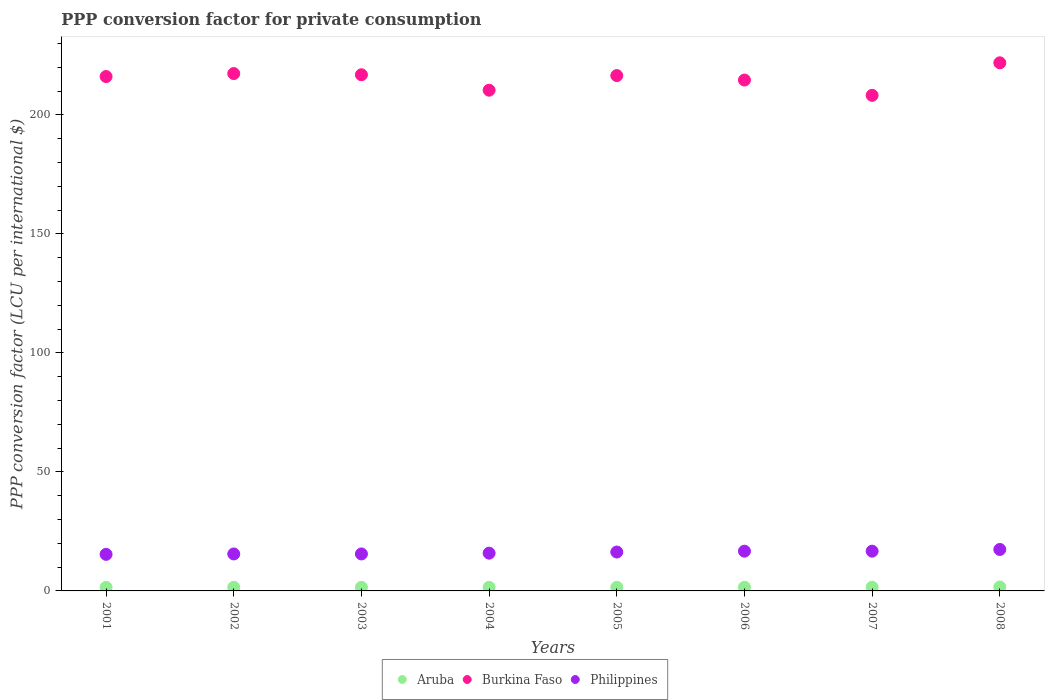Is the number of dotlines equal to the number of legend labels?
Provide a succinct answer. Yes. What is the PPP conversion factor for private consumption in Philippines in 2003?
Keep it short and to the point. 15.54. Across all years, what is the maximum PPP conversion factor for private consumption in Burkina Faso?
Your response must be concise. 221.91. Across all years, what is the minimum PPP conversion factor for private consumption in Philippines?
Provide a short and direct response. 15.36. In which year was the PPP conversion factor for private consumption in Burkina Faso maximum?
Make the answer very short. 2008. In which year was the PPP conversion factor for private consumption in Burkina Faso minimum?
Offer a terse response. 2007. What is the total PPP conversion factor for private consumption in Philippines in the graph?
Provide a short and direct response. 129.47. What is the difference between the PPP conversion factor for private consumption in Burkina Faso in 2003 and that in 2005?
Make the answer very short. 0.35. What is the difference between the PPP conversion factor for private consumption in Aruba in 2001 and the PPP conversion factor for private consumption in Burkina Faso in 2008?
Keep it short and to the point. -220.42. What is the average PPP conversion factor for private consumption in Philippines per year?
Your response must be concise. 16.18. In the year 2006, what is the difference between the PPP conversion factor for private consumption in Burkina Faso and PPP conversion factor for private consumption in Aruba?
Your answer should be compact. 213.12. In how many years, is the PPP conversion factor for private consumption in Aruba greater than 140 LCU?
Offer a very short reply. 0. What is the ratio of the PPP conversion factor for private consumption in Burkina Faso in 2006 to that in 2008?
Keep it short and to the point. 0.97. Is the PPP conversion factor for private consumption in Burkina Faso in 2003 less than that in 2006?
Provide a short and direct response. No. What is the difference between the highest and the second highest PPP conversion factor for private consumption in Aruba?
Offer a very short reply. 0.08. What is the difference between the highest and the lowest PPP conversion factor for private consumption in Philippines?
Keep it short and to the point. 2.06. In how many years, is the PPP conversion factor for private consumption in Aruba greater than the average PPP conversion factor for private consumption in Aruba taken over all years?
Your answer should be very brief. 2. Is the sum of the PPP conversion factor for private consumption in Aruba in 2003 and 2004 greater than the maximum PPP conversion factor for private consumption in Philippines across all years?
Offer a terse response. No. Is it the case that in every year, the sum of the PPP conversion factor for private consumption in Aruba and PPP conversion factor for private consumption in Burkina Faso  is greater than the PPP conversion factor for private consumption in Philippines?
Your response must be concise. Yes. Is the PPP conversion factor for private consumption in Aruba strictly greater than the PPP conversion factor for private consumption in Burkina Faso over the years?
Your answer should be compact. No. How many dotlines are there?
Ensure brevity in your answer.  3. How many years are there in the graph?
Provide a succinct answer. 8. Does the graph contain any zero values?
Offer a very short reply. No. Does the graph contain grids?
Provide a succinct answer. No. What is the title of the graph?
Make the answer very short. PPP conversion factor for private consumption. What is the label or title of the Y-axis?
Your answer should be compact. PPP conversion factor (LCU per international $). What is the PPP conversion factor (LCU per international $) of Aruba in 2001?
Your answer should be very brief. 1.49. What is the PPP conversion factor (LCU per international $) in Burkina Faso in 2001?
Provide a succinct answer. 216.13. What is the PPP conversion factor (LCU per international $) in Philippines in 2001?
Give a very brief answer. 15.36. What is the PPP conversion factor (LCU per international $) in Aruba in 2002?
Your response must be concise. 1.52. What is the PPP conversion factor (LCU per international $) of Burkina Faso in 2002?
Your response must be concise. 217.39. What is the PPP conversion factor (LCU per international $) in Philippines in 2002?
Offer a very short reply. 15.53. What is the PPP conversion factor (LCU per international $) of Aruba in 2003?
Provide a short and direct response. 1.54. What is the PPP conversion factor (LCU per international $) in Burkina Faso in 2003?
Your response must be concise. 216.89. What is the PPP conversion factor (LCU per international $) in Philippines in 2003?
Your answer should be compact. 15.54. What is the PPP conversion factor (LCU per international $) in Aruba in 2004?
Your answer should be compact. 1.53. What is the PPP conversion factor (LCU per international $) in Burkina Faso in 2004?
Keep it short and to the point. 210.39. What is the PPP conversion factor (LCU per international $) of Philippines in 2004?
Provide a succinct answer. 15.86. What is the PPP conversion factor (LCU per international $) of Aruba in 2005?
Your answer should be very brief. 1.53. What is the PPP conversion factor (LCU per international $) in Burkina Faso in 2005?
Ensure brevity in your answer.  216.54. What is the PPP conversion factor (LCU per international $) of Philippines in 2005?
Keep it short and to the point. 16.34. What is the PPP conversion factor (LCU per international $) of Aruba in 2006?
Ensure brevity in your answer.  1.54. What is the PPP conversion factor (LCU per international $) of Burkina Faso in 2006?
Provide a succinct answer. 214.66. What is the PPP conversion factor (LCU per international $) in Philippines in 2006?
Ensure brevity in your answer.  16.7. What is the PPP conversion factor (LCU per international $) of Aruba in 2007?
Your answer should be compact. 1.58. What is the PPP conversion factor (LCU per international $) of Burkina Faso in 2007?
Your answer should be very brief. 208.23. What is the PPP conversion factor (LCU per international $) in Philippines in 2007?
Your response must be concise. 16.71. What is the PPP conversion factor (LCU per international $) in Aruba in 2008?
Keep it short and to the point. 1.66. What is the PPP conversion factor (LCU per international $) in Burkina Faso in 2008?
Ensure brevity in your answer.  221.91. What is the PPP conversion factor (LCU per international $) in Philippines in 2008?
Provide a short and direct response. 17.42. Across all years, what is the maximum PPP conversion factor (LCU per international $) of Aruba?
Keep it short and to the point. 1.66. Across all years, what is the maximum PPP conversion factor (LCU per international $) of Burkina Faso?
Provide a short and direct response. 221.91. Across all years, what is the maximum PPP conversion factor (LCU per international $) of Philippines?
Your answer should be compact. 17.42. Across all years, what is the minimum PPP conversion factor (LCU per international $) of Aruba?
Ensure brevity in your answer.  1.49. Across all years, what is the minimum PPP conversion factor (LCU per international $) of Burkina Faso?
Provide a short and direct response. 208.23. Across all years, what is the minimum PPP conversion factor (LCU per international $) in Philippines?
Offer a terse response. 15.36. What is the total PPP conversion factor (LCU per international $) in Aruba in the graph?
Offer a very short reply. 12.39. What is the total PPP conversion factor (LCU per international $) of Burkina Faso in the graph?
Your answer should be very brief. 1722.13. What is the total PPP conversion factor (LCU per international $) in Philippines in the graph?
Keep it short and to the point. 129.47. What is the difference between the PPP conversion factor (LCU per international $) of Aruba in 2001 and that in 2002?
Provide a succinct answer. -0.03. What is the difference between the PPP conversion factor (LCU per international $) in Burkina Faso in 2001 and that in 2002?
Your answer should be very brief. -1.25. What is the difference between the PPP conversion factor (LCU per international $) of Philippines in 2001 and that in 2002?
Your response must be concise. -0.17. What is the difference between the PPP conversion factor (LCU per international $) of Aruba in 2001 and that in 2003?
Provide a short and direct response. -0.05. What is the difference between the PPP conversion factor (LCU per international $) of Burkina Faso in 2001 and that in 2003?
Your answer should be compact. -0.75. What is the difference between the PPP conversion factor (LCU per international $) in Philippines in 2001 and that in 2003?
Offer a terse response. -0.17. What is the difference between the PPP conversion factor (LCU per international $) of Aruba in 2001 and that in 2004?
Ensure brevity in your answer.  -0.04. What is the difference between the PPP conversion factor (LCU per international $) in Burkina Faso in 2001 and that in 2004?
Your response must be concise. 5.75. What is the difference between the PPP conversion factor (LCU per international $) in Philippines in 2001 and that in 2004?
Make the answer very short. -0.5. What is the difference between the PPP conversion factor (LCU per international $) in Aruba in 2001 and that in 2005?
Keep it short and to the point. -0.04. What is the difference between the PPP conversion factor (LCU per international $) in Burkina Faso in 2001 and that in 2005?
Give a very brief answer. -0.4. What is the difference between the PPP conversion factor (LCU per international $) of Philippines in 2001 and that in 2005?
Offer a very short reply. -0.98. What is the difference between the PPP conversion factor (LCU per international $) of Aruba in 2001 and that in 2006?
Ensure brevity in your answer.  -0.05. What is the difference between the PPP conversion factor (LCU per international $) in Burkina Faso in 2001 and that in 2006?
Provide a succinct answer. 1.47. What is the difference between the PPP conversion factor (LCU per international $) of Philippines in 2001 and that in 2006?
Your answer should be very brief. -1.34. What is the difference between the PPP conversion factor (LCU per international $) of Aruba in 2001 and that in 2007?
Offer a terse response. -0.09. What is the difference between the PPP conversion factor (LCU per international $) of Burkina Faso in 2001 and that in 2007?
Your answer should be compact. 7.9. What is the difference between the PPP conversion factor (LCU per international $) of Philippines in 2001 and that in 2007?
Provide a short and direct response. -1.35. What is the difference between the PPP conversion factor (LCU per international $) of Aruba in 2001 and that in 2008?
Your answer should be compact. -0.17. What is the difference between the PPP conversion factor (LCU per international $) in Burkina Faso in 2001 and that in 2008?
Your response must be concise. -5.77. What is the difference between the PPP conversion factor (LCU per international $) of Philippines in 2001 and that in 2008?
Give a very brief answer. -2.06. What is the difference between the PPP conversion factor (LCU per international $) in Aruba in 2002 and that in 2003?
Keep it short and to the point. -0.02. What is the difference between the PPP conversion factor (LCU per international $) in Burkina Faso in 2002 and that in 2003?
Give a very brief answer. 0.5. What is the difference between the PPP conversion factor (LCU per international $) of Philippines in 2002 and that in 2003?
Make the answer very short. -0. What is the difference between the PPP conversion factor (LCU per international $) of Aruba in 2002 and that in 2004?
Keep it short and to the point. -0.02. What is the difference between the PPP conversion factor (LCU per international $) of Burkina Faso in 2002 and that in 2004?
Ensure brevity in your answer.  7. What is the difference between the PPP conversion factor (LCU per international $) in Philippines in 2002 and that in 2004?
Your response must be concise. -0.33. What is the difference between the PPP conversion factor (LCU per international $) in Aruba in 2002 and that in 2005?
Keep it short and to the point. -0.02. What is the difference between the PPP conversion factor (LCU per international $) of Burkina Faso in 2002 and that in 2005?
Your response must be concise. 0.85. What is the difference between the PPP conversion factor (LCU per international $) in Philippines in 2002 and that in 2005?
Your response must be concise. -0.81. What is the difference between the PPP conversion factor (LCU per international $) in Aruba in 2002 and that in 2006?
Offer a very short reply. -0.02. What is the difference between the PPP conversion factor (LCU per international $) of Burkina Faso in 2002 and that in 2006?
Keep it short and to the point. 2.72. What is the difference between the PPP conversion factor (LCU per international $) of Philippines in 2002 and that in 2006?
Your response must be concise. -1.17. What is the difference between the PPP conversion factor (LCU per international $) of Aruba in 2002 and that in 2007?
Your answer should be very brief. -0.06. What is the difference between the PPP conversion factor (LCU per international $) of Burkina Faso in 2002 and that in 2007?
Your answer should be very brief. 9.16. What is the difference between the PPP conversion factor (LCU per international $) in Philippines in 2002 and that in 2007?
Your response must be concise. -1.17. What is the difference between the PPP conversion factor (LCU per international $) of Aruba in 2002 and that in 2008?
Make the answer very short. -0.14. What is the difference between the PPP conversion factor (LCU per international $) in Burkina Faso in 2002 and that in 2008?
Provide a short and direct response. -4.52. What is the difference between the PPP conversion factor (LCU per international $) in Philippines in 2002 and that in 2008?
Your answer should be very brief. -1.88. What is the difference between the PPP conversion factor (LCU per international $) in Aruba in 2003 and that in 2004?
Your answer should be compact. 0. What is the difference between the PPP conversion factor (LCU per international $) of Burkina Faso in 2003 and that in 2004?
Ensure brevity in your answer.  6.5. What is the difference between the PPP conversion factor (LCU per international $) of Philippines in 2003 and that in 2004?
Your answer should be compact. -0.33. What is the difference between the PPP conversion factor (LCU per international $) in Aruba in 2003 and that in 2005?
Keep it short and to the point. 0. What is the difference between the PPP conversion factor (LCU per international $) of Burkina Faso in 2003 and that in 2005?
Provide a short and direct response. 0.35. What is the difference between the PPP conversion factor (LCU per international $) in Philippines in 2003 and that in 2005?
Provide a short and direct response. -0.81. What is the difference between the PPP conversion factor (LCU per international $) of Aruba in 2003 and that in 2006?
Offer a terse response. -0. What is the difference between the PPP conversion factor (LCU per international $) in Burkina Faso in 2003 and that in 2006?
Keep it short and to the point. 2.22. What is the difference between the PPP conversion factor (LCU per international $) in Philippines in 2003 and that in 2006?
Your answer should be compact. -1.16. What is the difference between the PPP conversion factor (LCU per international $) of Aruba in 2003 and that in 2007?
Your response must be concise. -0.04. What is the difference between the PPP conversion factor (LCU per international $) of Burkina Faso in 2003 and that in 2007?
Offer a terse response. 8.66. What is the difference between the PPP conversion factor (LCU per international $) of Philippines in 2003 and that in 2007?
Give a very brief answer. -1.17. What is the difference between the PPP conversion factor (LCU per international $) in Aruba in 2003 and that in 2008?
Make the answer very short. -0.12. What is the difference between the PPP conversion factor (LCU per international $) in Burkina Faso in 2003 and that in 2008?
Offer a terse response. -5.02. What is the difference between the PPP conversion factor (LCU per international $) in Philippines in 2003 and that in 2008?
Offer a very short reply. -1.88. What is the difference between the PPP conversion factor (LCU per international $) in Aruba in 2004 and that in 2005?
Your response must be concise. -0. What is the difference between the PPP conversion factor (LCU per international $) of Burkina Faso in 2004 and that in 2005?
Provide a succinct answer. -6.15. What is the difference between the PPP conversion factor (LCU per international $) in Philippines in 2004 and that in 2005?
Offer a terse response. -0.48. What is the difference between the PPP conversion factor (LCU per international $) in Aruba in 2004 and that in 2006?
Your answer should be compact. -0.01. What is the difference between the PPP conversion factor (LCU per international $) in Burkina Faso in 2004 and that in 2006?
Provide a short and direct response. -4.28. What is the difference between the PPP conversion factor (LCU per international $) in Philippines in 2004 and that in 2006?
Provide a short and direct response. -0.84. What is the difference between the PPP conversion factor (LCU per international $) of Aruba in 2004 and that in 2007?
Keep it short and to the point. -0.04. What is the difference between the PPP conversion factor (LCU per international $) of Burkina Faso in 2004 and that in 2007?
Make the answer very short. 2.16. What is the difference between the PPP conversion factor (LCU per international $) of Philippines in 2004 and that in 2007?
Your response must be concise. -0.84. What is the difference between the PPP conversion factor (LCU per international $) in Aruba in 2004 and that in 2008?
Your response must be concise. -0.12. What is the difference between the PPP conversion factor (LCU per international $) in Burkina Faso in 2004 and that in 2008?
Your answer should be compact. -11.52. What is the difference between the PPP conversion factor (LCU per international $) of Philippines in 2004 and that in 2008?
Provide a short and direct response. -1.56. What is the difference between the PPP conversion factor (LCU per international $) of Aruba in 2005 and that in 2006?
Your response must be concise. -0.01. What is the difference between the PPP conversion factor (LCU per international $) of Burkina Faso in 2005 and that in 2006?
Your response must be concise. 1.87. What is the difference between the PPP conversion factor (LCU per international $) in Philippines in 2005 and that in 2006?
Your answer should be compact. -0.36. What is the difference between the PPP conversion factor (LCU per international $) in Aruba in 2005 and that in 2007?
Ensure brevity in your answer.  -0.04. What is the difference between the PPP conversion factor (LCU per international $) in Burkina Faso in 2005 and that in 2007?
Your response must be concise. 8.31. What is the difference between the PPP conversion factor (LCU per international $) of Philippines in 2005 and that in 2007?
Make the answer very short. -0.37. What is the difference between the PPP conversion factor (LCU per international $) of Aruba in 2005 and that in 2008?
Ensure brevity in your answer.  -0.12. What is the difference between the PPP conversion factor (LCU per international $) in Burkina Faso in 2005 and that in 2008?
Keep it short and to the point. -5.37. What is the difference between the PPP conversion factor (LCU per international $) of Philippines in 2005 and that in 2008?
Your answer should be compact. -1.08. What is the difference between the PPP conversion factor (LCU per international $) in Aruba in 2006 and that in 2007?
Your answer should be compact. -0.04. What is the difference between the PPP conversion factor (LCU per international $) of Burkina Faso in 2006 and that in 2007?
Provide a short and direct response. 6.44. What is the difference between the PPP conversion factor (LCU per international $) of Philippines in 2006 and that in 2007?
Offer a terse response. -0.01. What is the difference between the PPP conversion factor (LCU per international $) in Aruba in 2006 and that in 2008?
Your response must be concise. -0.12. What is the difference between the PPP conversion factor (LCU per international $) in Burkina Faso in 2006 and that in 2008?
Provide a succinct answer. -7.24. What is the difference between the PPP conversion factor (LCU per international $) of Philippines in 2006 and that in 2008?
Provide a succinct answer. -0.72. What is the difference between the PPP conversion factor (LCU per international $) in Aruba in 2007 and that in 2008?
Make the answer very short. -0.08. What is the difference between the PPP conversion factor (LCU per international $) in Burkina Faso in 2007 and that in 2008?
Ensure brevity in your answer.  -13.68. What is the difference between the PPP conversion factor (LCU per international $) in Philippines in 2007 and that in 2008?
Give a very brief answer. -0.71. What is the difference between the PPP conversion factor (LCU per international $) of Aruba in 2001 and the PPP conversion factor (LCU per international $) of Burkina Faso in 2002?
Your answer should be very brief. -215.9. What is the difference between the PPP conversion factor (LCU per international $) in Aruba in 2001 and the PPP conversion factor (LCU per international $) in Philippines in 2002?
Ensure brevity in your answer.  -14.04. What is the difference between the PPP conversion factor (LCU per international $) in Burkina Faso in 2001 and the PPP conversion factor (LCU per international $) in Philippines in 2002?
Provide a succinct answer. 200.6. What is the difference between the PPP conversion factor (LCU per international $) of Aruba in 2001 and the PPP conversion factor (LCU per international $) of Burkina Faso in 2003?
Ensure brevity in your answer.  -215.4. What is the difference between the PPP conversion factor (LCU per international $) in Aruba in 2001 and the PPP conversion factor (LCU per international $) in Philippines in 2003?
Ensure brevity in your answer.  -14.05. What is the difference between the PPP conversion factor (LCU per international $) in Burkina Faso in 2001 and the PPP conversion factor (LCU per international $) in Philippines in 2003?
Ensure brevity in your answer.  200.6. What is the difference between the PPP conversion factor (LCU per international $) of Aruba in 2001 and the PPP conversion factor (LCU per international $) of Burkina Faso in 2004?
Keep it short and to the point. -208.9. What is the difference between the PPP conversion factor (LCU per international $) of Aruba in 2001 and the PPP conversion factor (LCU per international $) of Philippines in 2004?
Your answer should be compact. -14.37. What is the difference between the PPP conversion factor (LCU per international $) of Burkina Faso in 2001 and the PPP conversion factor (LCU per international $) of Philippines in 2004?
Your answer should be very brief. 200.27. What is the difference between the PPP conversion factor (LCU per international $) in Aruba in 2001 and the PPP conversion factor (LCU per international $) in Burkina Faso in 2005?
Your response must be concise. -215.05. What is the difference between the PPP conversion factor (LCU per international $) in Aruba in 2001 and the PPP conversion factor (LCU per international $) in Philippines in 2005?
Make the answer very short. -14.85. What is the difference between the PPP conversion factor (LCU per international $) in Burkina Faso in 2001 and the PPP conversion factor (LCU per international $) in Philippines in 2005?
Make the answer very short. 199.79. What is the difference between the PPP conversion factor (LCU per international $) of Aruba in 2001 and the PPP conversion factor (LCU per international $) of Burkina Faso in 2006?
Ensure brevity in your answer.  -213.17. What is the difference between the PPP conversion factor (LCU per international $) in Aruba in 2001 and the PPP conversion factor (LCU per international $) in Philippines in 2006?
Keep it short and to the point. -15.21. What is the difference between the PPP conversion factor (LCU per international $) in Burkina Faso in 2001 and the PPP conversion factor (LCU per international $) in Philippines in 2006?
Ensure brevity in your answer.  199.43. What is the difference between the PPP conversion factor (LCU per international $) in Aruba in 2001 and the PPP conversion factor (LCU per international $) in Burkina Faso in 2007?
Your answer should be very brief. -206.74. What is the difference between the PPP conversion factor (LCU per international $) of Aruba in 2001 and the PPP conversion factor (LCU per international $) of Philippines in 2007?
Keep it short and to the point. -15.22. What is the difference between the PPP conversion factor (LCU per international $) of Burkina Faso in 2001 and the PPP conversion factor (LCU per international $) of Philippines in 2007?
Provide a succinct answer. 199.43. What is the difference between the PPP conversion factor (LCU per international $) in Aruba in 2001 and the PPP conversion factor (LCU per international $) in Burkina Faso in 2008?
Your answer should be compact. -220.42. What is the difference between the PPP conversion factor (LCU per international $) of Aruba in 2001 and the PPP conversion factor (LCU per international $) of Philippines in 2008?
Make the answer very short. -15.93. What is the difference between the PPP conversion factor (LCU per international $) of Burkina Faso in 2001 and the PPP conversion factor (LCU per international $) of Philippines in 2008?
Your answer should be very brief. 198.71. What is the difference between the PPP conversion factor (LCU per international $) of Aruba in 2002 and the PPP conversion factor (LCU per international $) of Burkina Faso in 2003?
Provide a succinct answer. -215.37. What is the difference between the PPP conversion factor (LCU per international $) in Aruba in 2002 and the PPP conversion factor (LCU per international $) in Philippines in 2003?
Your answer should be compact. -14.02. What is the difference between the PPP conversion factor (LCU per international $) in Burkina Faso in 2002 and the PPP conversion factor (LCU per international $) in Philippines in 2003?
Offer a terse response. 201.85. What is the difference between the PPP conversion factor (LCU per international $) of Aruba in 2002 and the PPP conversion factor (LCU per international $) of Burkina Faso in 2004?
Your answer should be compact. -208.87. What is the difference between the PPP conversion factor (LCU per international $) in Aruba in 2002 and the PPP conversion factor (LCU per international $) in Philippines in 2004?
Give a very brief answer. -14.35. What is the difference between the PPP conversion factor (LCU per international $) in Burkina Faso in 2002 and the PPP conversion factor (LCU per international $) in Philippines in 2004?
Keep it short and to the point. 201.52. What is the difference between the PPP conversion factor (LCU per international $) in Aruba in 2002 and the PPP conversion factor (LCU per international $) in Burkina Faso in 2005?
Your response must be concise. -215.02. What is the difference between the PPP conversion factor (LCU per international $) of Aruba in 2002 and the PPP conversion factor (LCU per international $) of Philippines in 2005?
Ensure brevity in your answer.  -14.83. What is the difference between the PPP conversion factor (LCU per international $) of Burkina Faso in 2002 and the PPP conversion factor (LCU per international $) of Philippines in 2005?
Your answer should be very brief. 201.05. What is the difference between the PPP conversion factor (LCU per international $) of Aruba in 2002 and the PPP conversion factor (LCU per international $) of Burkina Faso in 2006?
Your answer should be very brief. -213.15. What is the difference between the PPP conversion factor (LCU per international $) in Aruba in 2002 and the PPP conversion factor (LCU per international $) in Philippines in 2006?
Provide a short and direct response. -15.18. What is the difference between the PPP conversion factor (LCU per international $) in Burkina Faso in 2002 and the PPP conversion factor (LCU per international $) in Philippines in 2006?
Keep it short and to the point. 200.69. What is the difference between the PPP conversion factor (LCU per international $) in Aruba in 2002 and the PPP conversion factor (LCU per international $) in Burkina Faso in 2007?
Your answer should be very brief. -206.71. What is the difference between the PPP conversion factor (LCU per international $) in Aruba in 2002 and the PPP conversion factor (LCU per international $) in Philippines in 2007?
Offer a terse response. -15.19. What is the difference between the PPP conversion factor (LCU per international $) in Burkina Faso in 2002 and the PPP conversion factor (LCU per international $) in Philippines in 2007?
Your answer should be very brief. 200.68. What is the difference between the PPP conversion factor (LCU per international $) of Aruba in 2002 and the PPP conversion factor (LCU per international $) of Burkina Faso in 2008?
Your response must be concise. -220.39. What is the difference between the PPP conversion factor (LCU per international $) in Aruba in 2002 and the PPP conversion factor (LCU per international $) in Philippines in 2008?
Offer a very short reply. -15.9. What is the difference between the PPP conversion factor (LCU per international $) of Burkina Faso in 2002 and the PPP conversion factor (LCU per international $) of Philippines in 2008?
Keep it short and to the point. 199.97. What is the difference between the PPP conversion factor (LCU per international $) in Aruba in 2003 and the PPP conversion factor (LCU per international $) in Burkina Faso in 2004?
Keep it short and to the point. -208.85. What is the difference between the PPP conversion factor (LCU per international $) in Aruba in 2003 and the PPP conversion factor (LCU per international $) in Philippines in 2004?
Provide a short and direct response. -14.33. What is the difference between the PPP conversion factor (LCU per international $) of Burkina Faso in 2003 and the PPP conversion factor (LCU per international $) of Philippines in 2004?
Make the answer very short. 201.02. What is the difference between the PPP conversion factor (LCU per international $) in Aruba in 2003 and the PPP conversion factor (LCU per international $) in Burkina Faso in 2005?
Make the answer very short. -215. What is the difference between the PPP conversion factor (LCU per international $) of Aruba in 2003 and the PPP conversion factor (LCU per international $) of Philippines in 2005?
Provide a short and direct response. -14.81. What is the difference between the PPP conversion factor (LCU per international $) of Burkina Faso in 2003 and the PPP conversion factor (LCU per international $) of Philippines in 2005?
Offer a very short reply. 200.54. What is the difference between the PPP conversion factor (LCU per international $) of Aruba in 2003 and the PPP conversion factor (LCU per international $) of Burkina Faso in 2006?
Offer a terse response. -213.13. What is the difference between the PPP conversion factor (LCU per international $) in Aruba in 2003 and the PPP conversion factor (LCU per international $) in Philippines in 2006?
Provide a succinct answer. -15.16. What is the difference between the PPP conversion factor (LCU per international $) in Burkina Faso in 2003 and the PPP conversion factor (LCU per international $) in Philippines in 2006?
Provide a succinct answer. 200.19. What is the difference between the PPP conversion factor (LCU per international $) of Aruba in 2003 and the PPP conversion factor (LCU per international $) of Burkina Faso in 2007?
Keep it short and to the point. -206.69. What is the difference between the PPP conversion factor (LCU per international $) of Aruba in 2003 and the PPP conversion factor (LCU per international $) of Philippines in 2007?
Offer a very short reply. -15.17. What is the difference between the PPP conversion factor (LCU per international $) in Burkina Faso in 2003 and the PPP conversion factor (LCU per international $) in Philippines in 2007?
Offer a very short reply. 200.18. What is the difference between the PPP conversion factor (LCU per international $) in Aruba in 2003 and the PPP conversion factor (LCU per international $) in Burkina Faso in 2008?
Make the answer very short. -220.37. What is the difference between the PPP conversion factor (LCU per international $) in Aruba in 2003 and the PPP conversion factor (LCU per international $) in Philippines in 2008?
Keep it short and to the point. -15.88. What is the difference between the PPP conversion factor (LCU per international $) in Burkina Faso in 2003 and the PPP conversion factor (LCU per international $) in Philippines in 2008?
Provide a succinct answer. 199.47. What is the difference between the PPP conversion factor (LCU per international $) in Aruba in 2004 and the PPP conversion factor (LCU per international $) in Burkina Faso in 2005?
Provide a succinct answer. -215. What is the difference between the PPP conversion factor (LCU per international $) in Aruba in 2004 and the PPP conversion factor (LCU per international $) in Philippines in 2005?
Provide a succinct answer. -14.81. What is the difference between the PPP conversion factor (LCU per international $) of Burkina Faso in 2004 and the PPP conversion factor (LCU per international $) of Philippines in 2005?
Provide a succinct answer. 194.04. What is the difference between the PPP conversion factor (LCU per international $) in Aruba in 2004 and the PPP conversion factor (LCU per international $) in Burkina Faso in 2006?
Provide a short and direct response. -213.13. What is the difference between the PPP conversion factor (LCU per international $) in Aruba in 2004 and the PPP conversion factor (LCU per international $) in Philippines in 2006?
Offer a very short reply. -15.17. What is the difference between the PPP conversion factor (LCU per international $) in Burkina Faso in 2004 and the PPP conversion factor (LCU per international $) in Philippines in 2006?
Provide a short and direct response. 193.69. What is the difference between the PPP conversion factor (LCU per international $) of Aruba in 2004 and the PPP conversion factor (LCU per international $) of Burkina Faso in 2007?
Provide a succinct answer. -206.69. What is the difference between the PPP conversion factor (LCU per international $) of Aruba in 2004 and the PPP conversion factor (LCU per international $) of Philippines in 2007?
Provide a short and direct response. -15.17. What is the difference between the PPP conversion factor (LCU per international $) of Burkina Faso in 2004 and the PPP conversion factor (LCU per international $) of Philippines in 2007?
Keep it short and to the point. 193.68. What is the difference between the PPP conversion factor (LCU per international $) in Aruba in 2004 and the PPP conversion factor (LCU per international $) in Burkina Faso in 2008?
Provide a succinct answer. -220.37. What is the difference between the PPP conversion factor (LCU per international $) in Aruba in 2004 and the PPP conversion factor (LCU per international $) in Philippines in 2008?
Give a very brief answer. -15.88. What is the difference between the PPP conversion factor (LCU per international $) in Burkina Faso in 2004 and the PPP conversion factor (LCU per international $) in Philippines in 2008?
Your answer should be very brief. 192.97. What is the difference between the PPP conversion factor (LCU per international $) of Aruba in 2005 and the PPP conversion factor (LCU per international $) of Burkina Faso in 2006?
Keep it short and to the point. -213.13. What is the difference between the PPP conversion factor (LCU per international $) of Aruba in 2005 and the PPP conversion factor (LCU per international $) of Philippines in 2006?
Your response must be concise. -15.17. What is the difference between the PPP conversion factor (LCU per international $) in Burkina Faso in 2005 and the PPP conversion factor (LCU per international $) in Philippines in 2006?
Your answer should be very brief. 199.84. What is the difference between the PPP conversion factor (LCU per international $) of Aruba in 2005 and the PPP conversion factor (LCU per international $) of Burkina Faso in 2007?
Offer a very short reply. -206.69. What is the difference between the PPP conversion factor (LCU per international $) of Aruba in 2005 and the PPP conversion factor (LCU per international $) of Philippines in 2007?
Offer a terse response. -15.17. What is the difference between the PPP conversion factor (LCU per international $) in Burkina Faso in 2005 and the PPP conversion factor (LCU per international $) in Philippines in 2007?
Make the answer very short. 199.83. What is the difference between the PPP conversion factor (LCU per international $) in Aruba in 2005 and the PPP conversion factor (LCU per international $) in Burkina Faso in 2008?
Give a very brief answer. -220.37. What is the difference between the PPP conversion factor (LCU per international $) of Aruba in 2005 and the PPP conversion factor (LCU per international $) of Philippines in 2008?
Provide a succinct answer. -15.88. What is the difference between the PPP conversion factor (LCU per international $) of Burkina Faso in 2005 and the PPP conversion factor (LCU per international $) of Philippines in 2008?
Your answer should be very brief. 199.12. What is the difference between the PPP conversion factor (LCU per international $) in Aruba in 2006 and the PPP conversion factor (LCU per international $) in Burkina Faso in 2007?
Your response must be concise. -206.69. What is the difference between the PPP conversion factor (LCU per international $) in Aruba in 2006 and the PPP conversion factor (LCU per international $) in Philippines in 2007?
Provide a succinct answer. -15.17. What is the difference between the PPP conversion factor (LCU per international $) in Burkina Faso in 2006 and the PPP conversion factor (LCU per international $) in Philippines in 2007?
Offer a terse response. 197.96. What is the difference between the PPP conversion factor (LCU per international $) in Aruba in 2006 and the PPP conversion factor (LCU per international $) in Burkina Faso in 2008?
Ensure brevity in your answer.  -220.37. What is the difference between the PPP conversion factor (LCU per international $) of Aruba in 2006 and the PPP conversion factor (LCU per international $) of Philippines in 2008?
Give a very brief answer. -15.88. What is the difference between the PPP conversion factor (LCU per international $) in Burkina Faso in 2006 and the PPP conversion factor (LCU per international $) in Philippines in 2008?
Ensure brevity in your answer.  197.24. What is the difference between the PPP conversion factor (LCU per international $) in Aruba in 2007 and the PPP conversion factor (LCU per international $) in Burkina Faso in 2008?
Give a very brief answer. -220.33. What is the difference between the PPP conversion factor (LCU per international $) in Aruba in 2007 and the PPP conversion factor (LCU per international $) in Philippines in 2008?
Your answer should be compact. -15.84. What is the difference between the PPP conversion factor (LCU per international $) of Burkina Faso in 2007 and the PPP conversion factor (LCU per international $) of Philippines in 2008?
Provide a short and direct response. 190.81. What is the average PPP conversion factor (LCU per international $) in Aruba per year?
Give a very brief answer. 1.55. What is the average PPP conversion factor (LCU per international $) in Burkina Faso per year?
Provide a succinct answer. 215.27. What is the average PPP conversion factor (LCU per international $) in Philippines per year?
Ensure brevity in your answer.  16.18. In the year 2001, what is the difference between the PPP conversion factor (LCU per international $) in Aruba and PPP conversion factor (LCU per international $) in Burkina Faso?
Offer a terse response. -214.64. In the year 2001, what is the difference between the PPP conversion factor (LCU per international $) of Aruba and PPP conversion factor (LCU per international $) of Philippines?
Give a very brief answer. -13.87. In the year 2001, what is the difference between the PPP conversion factor (LCU per international $) of Burkina Faso and PPP conversion factor (LCU per international $) of Philippines?
Provide a succinct answer. 200.77. In the year 2002, what is the difference between the PPP conversion factor (LCU per international $) in Aruba and PPP conversion factor (LCU per international $) in Burkina Faso?
Ensure brevity in your answer.  -215.87. In the year 2002, what is the difference between the PPP conversion factor (LCU per international $) of Aruba and PPP conversion factor (LCU per international $) of Philippines?
Keep it short and to the point. -14.02. In the year 2002, what is the difference between the PPP conversion factor (LCU per international $) in Burkina Faso and PPP conversion factor (LCU per international $) in Philippines?
Your answer should be very brief. 201.85. In the year 2003, what is the difference between the PPP conversion factor (LCU per international $) of Aruba and PPP conversion factor (LCU per international $) of Burkina Faso?
Offer a terse response. -215.35. In the year 2003, what is the difference between the PPP conversion factor (LCU per international $) of Aruba and PPP conversion factor (LCU per international $) of Philippines?
Keep it short and to the point. -14. In the year 2003, what is the difference between the PPP conversion factor (LCU per international $) of Burkina Faso and PPP conversion factor (LCU per international $) of Philippines?
Your response must be concise. 201.35. In the year 2004, what is the difference between the PPP conversion factor (LCU per international $) of Aruba and PPP conversion factor (LCU per international $) of Burkina Faso?
Offer a very short reply. -208.85. In the year 2004, what is the difference between the PPP conversion factor (LCU per international $) in Aruba and PPP conversion factor (LCU per international $) in Philippines?
Provide a short and direct response. -14.33. In the year 2004, what is the difference between the PPP conversion factor (LCU per international $) of Burkina Faso and PPP conversion factor (LCU per international $) of Philippines?
Keep it short and to the point. 194.52. In the year 2005, what is the difference between the PPP conversion factor (LCU per international $) of Aruba and PPP conversion factor (LCU per international $) of Burkina Faso?
Provide a short and direct response. -215. In the year 2005, what is the difference between the PPP conversion factor (LCU per international $) of Aruba and PPP conversion factor (LCU per international $) of Philippines?
Make the answer very short. -14.81. In the year 2005, what is the difference between the PPP conversion factor (LCU per international $) in Burkina Faso and PPP conversion factor (LCU per international $) in Philippines?
Offer a terse response. 200.19. In the year 2006, what is the difference between the PPP conversion factor (LCU per international $) in Aruba and PPP conversion factor (LCU per international $) in Burkina Faso?
Your response must be concise. -213.12. In the year 2006, what is the difference between the PPP conversion factor (LCU per international $) of Aruba and PPP conversion factor (LCU per international $) of Philippines?
Offer a terse response. -15.16. In the year 2006, what is the difference between the PPP conversion factor (LCU per international $) in Burkina Faso and PPP conversion factor (LCU per international $) in Philippines?
Keep it short and to the point. 197.96. In the year 2007, what is the difference between the PPP conversion factor (LCU per international $) of Aruba and PPP conversion factor (LCU per international $) of Burkina Faso?
Offer a very short reply. -206.65. In the year 2007, what is the difference between the PPP conversion factor (LCU per international $) in Aruba and PPP conversion factor (LCU per international $) in Philippines?
Your answer should be very brief. -15.13. In the year 2007, what is the difference between the PPP conversion factor (LCU per international $) in Burkina Faso and PPP conversion factor (LCU per international $) in Philippines?
Your answer should be very brief. 191.52. In the year 2008, what is the difference between the PPP conversion factor (LCU per international $) in Aruba and PPP conversion factor (LCU per international $) in Burkina Faso?
Make the answer very short. -220.25. In the year 2008, what is the difference between the PPP conversion factor (LCU per international $) in Aruba and PPP conversion factor (LCU per international $) in Philippines?
Your response must be concise. -15.76. In the year 2008, what is the difference between the PPP conversion factor (LCU per international $) of Burkina Faso and PPP conversion factor (LCU per international $) of Philippines?
Make the answer very short. 204.49. What is the ratio of the PPP conversion factor (LCU per international $) in Aruba in 2001 to that in 2002?
Give a very brief answer. 0.98. What is the ratio of the PPP conversion factor (LCU per international $) in Philippines in 2001 to that in 2002?
Your answer should be very brief. 0.99. What is the ratio of the PPP conversion factor (LCU per international $) of Aruba in 2001 to that in 2003?
Make the answer very short. 0.97. What is the ratio of the PPP conversion factor (LCU per international $) in Burkina Faso in 2001 to that in 2003?
Make the answer very short. 1. What is the ratio of the PPP conversion factor (LCU per international $) in Philippines in 2001 to that in 2003?
Make the answer very short. 0.99. What is the ratio of the PPP conversion factor (LCU per international $) of Aruba in 2001 to that in 2004?
Offer a terse response. 0.97. What is the ratio of the PPP conversion factor (LCU per international $) in Burkina Faso in 2001 to that in 2004?
Your response must be concise. 1.03. What is the ratio of the PPP conversion factor (LCU per international $) of Philippines in 2001 to that in 2004?
Offer a very short reply. 0.97. What is the ratio of the PPP conversion factor (LCU per international $) of Aruba in 2001 to that in 2005?
Ensure brevity in your answer.  0.97. What is the ratio of the PPP conversion factor (LCU per international $) of Burkina Faso in 2001 to that in 2005?
Offer a terse response. 1. What is the ratio of the PPP conversion factor (LCU per international $) in Aruba in 2001 to that in 2006?
Provide a succinct answer. 0.97. What is the ratio of the PPP conversion factor (LCU per international $) of Burkina Faso in 2001 to that in 2006?
Keep it short and to the point. 1.01. What is the ratio of the PPP conversion factor (LCU per international $) in Philippines in 2001 to that in 2006?
Your response must be concise. 0.92. What is the ratio of the PPP conversion factor (LCU per international $) in Aruba in 2001 to that in 2007?
Your response must be concise. 0.94. What is the ratio of the PPP conversion factor (LCU per international $) of Burkina Faso in 2001 to that in 2007?
Offer a very short reply. 1.04. What is the ratio of the PPP conversion factor (LCU per international $) of Philippines in 2001 to that in 2007?
Offer a terse response. 0.92. What is the ratio of the PPP conversion factor (LCU per international $) of Aruba in 2001 to that in 2008?
Ensure brevity in your answer.  0.9. What is the ratio of the PPP conversion factor (LCU per international $) in Philippines in 2001 to that in 2008?
Make the answer very short. 0.88. What is the ratio of the PPP conversion factor (LCU per international $) in Aruba in 2002 to that in 2003?
Provide a succinct answer. 0.99. What is the ratio of the PPP conversion factor (LCU per international $) of Philippines in 2002 to that in 2003?
Your answer should be compact. 1. What is the ratio of the PPP conversion factor (LCU per international $) in Philippines in 2002 to that in 2004?
Give a very brief answer. 0.98. What is the ratio of the PPP conversion factor (LCU per international $) of Burkina Faso in 2002 to that in 2005?
Provide a succinct answer. 1. What is the ratio of the PPP conversion factor (LCU per international $) in Philippines in 2002 to that in 2005?
Ensure brevity in your answer.  0.95. What is the ratio of the PPP conversion factor (LCU per international $) of Aruba in 2002 to that in 2006?
Give a very brief answer. 0.98. What is the ratio of the PPP conversion factor (LCU per international $) in Burkina Faso in 2002 to that in 2006?
Give a very brief answer. 1.01. What is the ratio of the PPP conversion factor (LCU per international $) in Philippines in 2002 to that in 2006?
Ensure brevity in your answer.  0.93. What is the ratio of the PPP conversion factor (LCU per international $) of Aruba in 2002 to that in 2007?
Provide a succinct answer. 0.96. What is the ratio of the PPP conversion factor (LCU per international $) in Burkina Faso in 2002 to that in 2007?
Your answer should be very brief. 1.04. What is the ratio of the PPP conversion factor (LCU per international $) of Philippines in 2002 to that in 2007?
Your answer should be compact. 0.93. What is the ratio of the PPP conversion factor (LCU per international $) in Aruba in 2002 to that in 2008?
Offer a very short reply. 0.92. What is the ratio of the PPP conversion factor (LCU per international $) of Burkina Faso in 2002 to that in 2008?
Offer a terse response. 0.98. What is the ratio of the PPP conversion factor (LCU per international $) in Philippines in 2002 to that in 2008?
Provide a succinct answer. 0.89. What is the ratio of the PPP conversion factor (LCU per international $) in Aruba in 2003 to that in 2004?
Your response must be concise. 1. What is the ratio of the PPP conversion factor (LCU per international $) in Burkina Faso in 2003 to that in 2004?
Offer a terse response. 1.03. What is the ratio of the PPP conversion factor (LCU per international $) in Philippines in 2003 to that in 2004?
Your answer should be compact. 0.98. What is the ratio of the PPP conversion factor (LCU per international $) in Burkina Faso in 2003 to that in 2005?
Offer a terse response. 1. What is the ratio of the PPP conversion factor (LCU per international $) of Philippines in 2003 to that in 2005?
Keep it short and to the point. 0.95. What is the ratio of the PPP conversion factor (LCU per international $) of Burkina Faso in 2003 to that in 2006?
Offer a very short reply. 1.01. What is the ratio of the PPP conversion factor (LCU per international $) in Philippines in 2003 to that in 2006?
Keep it short and to the point. 0.93. What is the ratio of the PPP conversion factor (LCU per international $) in Aruba in 2003 to that in 2007?
Provide a short and direct response. 0.97. What is the ratio of the PPP conversion factor (LCU per international $) of Burkina Faso in 2003 to that in 2007?
Provide a short and direct response. 1.04. What is the ratio of the PPP conversion factor (LCU per international $) in Aruba in 2003 to that in 2008?
Ensure brevity in your answer.  0.93. What is the ratio of the PPP conversion factor (LCU per international $) of Burkina Faso in 2003 to that in 2008?
Provide a short and direct response. 0.98. What is the ratio of the PPP conversion factor (LCU per international $) in Philippines in 2003 to that in 2008?
Give a very brief answer. 0.89. What is the ratio of the PPP conversion factor (LCU per international $) in Burkina Faso in 2004 to that in 2005?
Ensure brevity in your answer.  0.97. What is the ratio of the PPP conversion factor (LCU per international $) in Philippines in 2004 to that in 2005?
Make the answer very short. 0.97. What is the ratio of the PPP conversion factor (LCU per international $) of Burkina Faso in 2004 to that in 2006?
Provide a succinct answer. 0.98. What is the ratio of the PPP conversion factor (LCU per international $) of Philippines in 2004 to that in 2006?
Your response must be concise. 0.95. What is the ratio of the PPP conversion factor (LCU per international $) of Aruba in 2004 to that in 2007?
Keep it short and to the point. 0.97. What is the ratio of the PPP conversion factor (LCU per international $) of Burkina Faso in 2004 to that in 2007?
Offer a terse response. 1.01. What is the ratio of the PPP conversion factor (LCU per international $) in Philippines in 2004 to that in 2007?
Give a very brief answer. 0.95. What is the ratio of the PPP conversion factor (LCU per international $) in Aruba in 2004 to that in 2008?
Provide a succinct answer. 0.93. What is the ratio of the PPP conversion factor (LCU per international $) in Burkina Faso in 2004 to that in 2008?
Offer a terse response. 0.95. What is the ratio of the PPP conversion factor (LCU per international $) of Philippines in 2004 to that in 2008?
Provide a succinct answer. 0.91. What is the ratio of the PPP conversion factor (LCU per international $) of Burkina Faso in 2005 to that in 2006?
Give a very brief answer. 1.01. What is the ratio of the PPP conversion factor (LCU per international $) in Philippines in 2005 to that in 2006?
Your answer should be very brief. 0.98. What is the ratio of the PPP conversion factor (LCU per international $) in Aruba in 2005 to that in 2007?
Provide a short and direct response. 0.97. What is the ratio of the PPP conversion factor (LCU per international $) of Burkina Faso in 2005 to that in 2007?
Your response must be concise. 1.04. What is the ratio of the PPP conversion factor (LCU per international $) in Philippines in 2005 to that in 2007?
Keep it short and to the point. 0.98. What is the ratio of the PPP conversion factor (LCU per international $) of Aruba in 2005 to that in 2008?
Ensure brevity in your answer.  0.93. What is the ratio of the PPP conversion factor (LCU per international $) of Burkina Faso in 2005 to that in 2008?
Your answer should be compact. 0.98. What is the ratio of the PPP conversion factor (LCU per international $) in Philippines in 2005 to that in 2008?
Your answer should be compact. 0.94. What is the ratio of the PPP conversion factor (LCU per international $) of Aruba in 2006 to that in 2007?
Give a very brief answer. 0.98. What is the ratio of the PPP conversion factor (LCU per international $) in Burkina Faso in 2006 to that in 2007?
Your answer should be very brief. 1.03. What is the ratio of the PPP conversion factor (LCU per international $) of Aruba in 2006 to that in 2008?
Your answer should be compact. 0.93. What is the ratio of the PPP conversion factor (LCU per international $) in Burkina Faso in 2006 to that in 2008?
Your answer should be compact. 0.97. What is the ratio of the PPP conversion factor (LCU per international $) in Philippines in 2006 to that in 2008?
Your answer should be compact. 0.96. What is the ratio of the PPP conversion factor (LCU per international $) of Aruba in 2007 to that in 2008?
Provide a succinct answer. 0.95. What is the ratio of the PPP conversion factor (LCU per international $) in Burkina Faso in 2007 to that in 2008?
Offer a terse response. 0.94. What is the ratio of the PPP conversion factor (LCU per international $) in Philippines in 2007 to that in 2008?
Your answer should be compact. 0.96. What is the difference between the highest and the second highest PPP conversion factor (LCU per international $) of Aruba?
Provide a succinct answer. 0.08. What is the difference between the highest and the second highest PPP conversion factor (LCU per international $) in Burkina Faso?
Your answer should be very brief. 4.52. What is the difference between the highest and the second highest PPP conversion factor (LCU per international $) of Philippines?
Provide a succinct answer. 0.71. What is the difference between the highest and the lowest PPP conversion factor (LCU per international $) of Aruba?
Your answer should be very brief. 0.17. What is the difference between the highest and the lowest PPP conversion factor (LCU per international $) of Burkina Faso?
Ensure brevity in your answer.  13.68. What is the difference between the highest and the lowest PPP conversion factor (LCU per international $) in Philippines?
Your answer should be very brief. 2.06. 